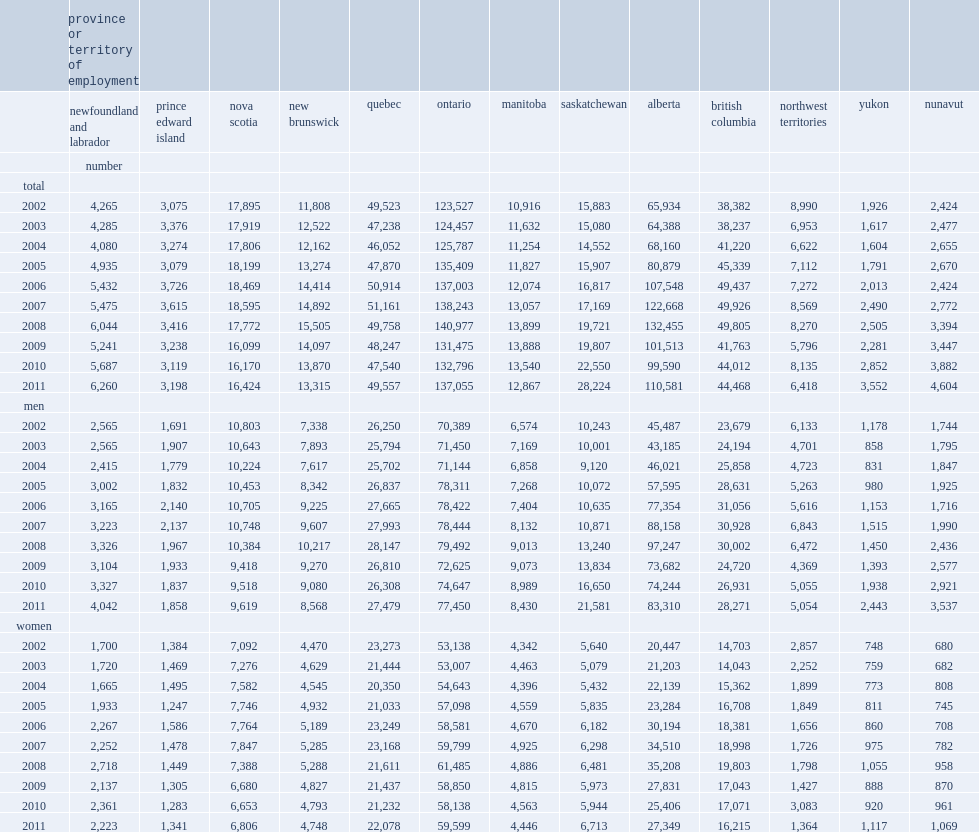How many interprovincial employees work in 'receiving' provinces or territories in 2011? 436523. Which province or territory receives the largest number of interprovincial employees in 2011? Ontario. How many interprovincial employees are in alberta in 2008? 132455.0. How many interprovincial employees are in alberta in 2009? 101513.0. How many interprovincial employees are in alberta in 2011? 110581.0. 